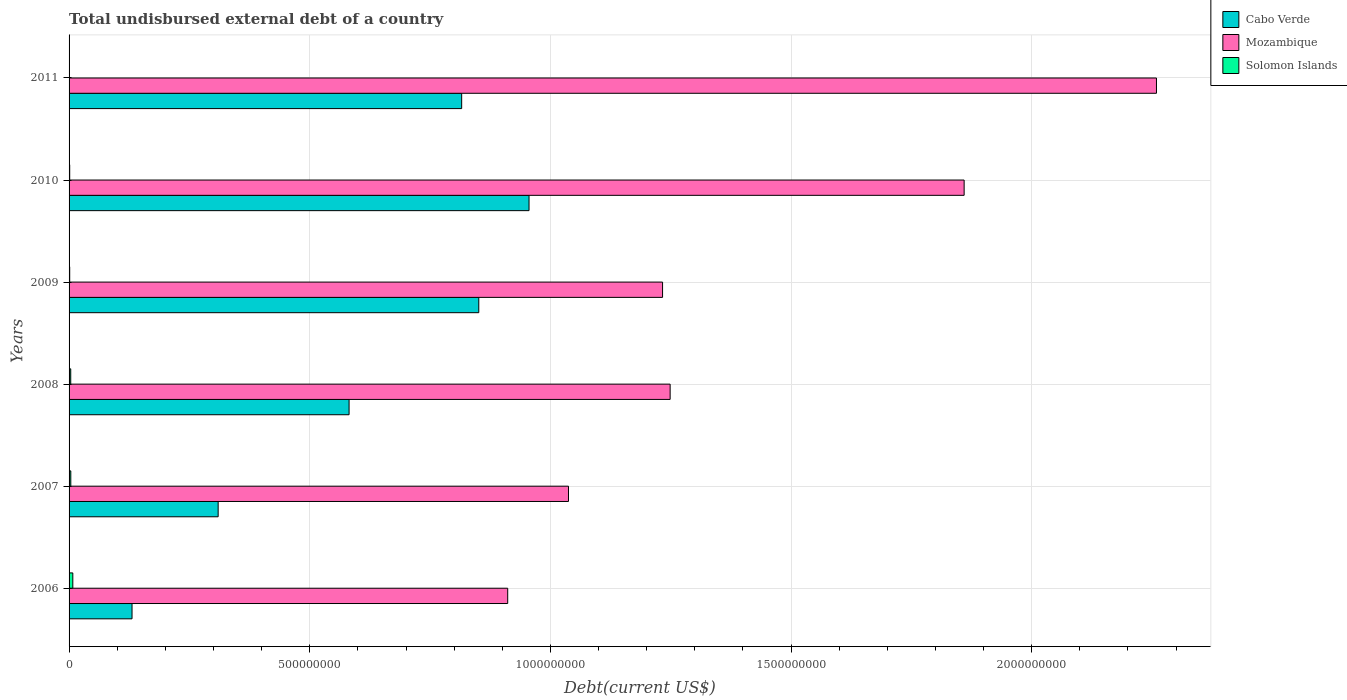How many different coloured bars are there?
Ensure brevity in your answer.  3. How many groups of bars are there?
Give a very brief answer. 6. Are the number of bars per tick equal to the number of legend labels?
Provide a succinct answer. Yes. How many bars are there on the 6th tick from the top?
Your response must be concise. 3. What is the label of the 1st group of bars from the top?
Offer a very short reply. 2011. What is the total undisbursed external debt in Mozambique in 2011?
Ensure brevity in your answer.  2.26e+09. Across all years, what is the maximum total undisbursed external debt in Solomon Islands?
Offer a very short reply. 7.76e+06. Across all years, what is the minimum total undisbursed external debt in Mozambique?
Your answer should be compact. 9.11e+08. In which year was the total undisbursed external debt in Mozambique minimum?
Your answer should be compact. 2006. What is the total total undisbursed external debt in Cabo Verde in the graph?
Keep it short and to the point. 3.64e+09. What is the difference between the total undisbursed external debt in Solomon Islands in 2007 and that in 2009?
Keep it short and to the point. 2.28e+06. What is the difference between the total undisbursed external debt in Mozambique in 2009 and the total undisbursed external debt in Cabo Verde in 2007?
Provide a succinct answer. 9.23e+08. What is the average total undisbursed external debt in Mozambique per year?
Your answer should be very brief. 1.42e+09. In the year 2008, what is the difference between the total undisbursed external debt in Mozambique and total undisbursed external debt in Solomon Islands?
Offer a very short reply. 1.25e+09. In how many years, is the total undisbursed external debt in Cabo Verde greater than 400000000 US$?
Provide a short and direct response. 4. What is the ratio of the total undisbursed external debt in Solomon Islands in 2009 to that in 2010?
Ensure brevity in your answer.  1. What is the difference between the highest and the second highest total undisbursed external debt in Cabo Verde?
Your response must be concise. 1.04e+08. What is the difference between the highest and the lowest total undisbursed external debt in Solomon Islands?
Your answer should be compact. 7.65e+06. In how many years, is the total undisbursed external debt in Solomon Islands greater than the average total undisbursed external debt in Solomon Islands taken over all years?
Keep it short and to the point. 3. What does the 2nd bar from the top in 2006 represents?
Your response must be concise. Mozambique. What does the 2nd bar from the bottom in 2009 represents?
Your answer should be compact. Mozambique. Is it the case that in every year, the sum of the total undisbursed external debt in Mozambique and total undisbursed external debt in Solomon Islands is greater than the total undisbursed external debt in Cabo Verde?
Offer a very short reply. Yes. What is the difference between two consecutive major ticks on the X-axis?
Make the answer very short. 5.00e+08. Are the values on the major ticks of X-axis written in scientific E-notation?
Your answer should be compact. No. Does the graph contain any zero values?
Your answer should be compact. No. Where does the legend appear in the graph?
Provide a succinct answer. Top right. How many legend labels are there?
Your answer should be very brief. 3. What is the title of the graph?
Offer a very short reply. Total undisbursed external debt of a country. Does "Northern Mariana Islands" appear as one of the legend labels in the graph?
Your answer should be very brief. No. What is the label or title of the X-axis?
Make the answer very short. Debt(current US$). What is the Debt(current US$) in Cabo Verde in 2006?
Make the answer very short. 1.31e+08. What is the Debt(current US$) of Mozambique in 2006?
Offer a terse response. 9.11e+08. What is the Debt(current US$) in Solomon Islands in 2006?
Your answer should be compact. 7.76e+06. What is the Debt(current US$) in Cabo Verde in 2007?
Provide a succinct answer. 3.10e+08. What is the Debt(current US$) in Mozambique in 2007?
Give a very brief answer. 1.04e+09. What is the Debt(current US$) in Solomon Islands in 2007?
Offer a very short reply. 3.60e+06. What is the Debt(current US$) in Cabo Verde in 2008?
Offer a very short reply. 5.82e+08. What is the Debt(current US$) of Mozambique in 2008?
Provide a short and direct response. 1.25e+09. What is the Debt(current US$) in Solomon Islands in 2008?
Provide a short and direct response. 3.46e+06. What is the Debt(current US$) of Cabo Verde in 2009?
Make the answer very short. 8.51e+08. What is the Debt(current US$) of Mozambique in 2009?
Keep it short and to the point. 1.23e+09. What is the Debt(current US$) of Solomon Islands in 2009?
Your answer should be compact. 1.32e+06. What is the Debt(current US$) of Cabo Verde in 2010?
Provide a short and direct response. 9.56e+08. What is the Debt(current US$) in Mozambique in 2010?
Your answer should be compact. 1.86e+09. What is the Debt(current US$) of Solomon Islands in 2010?
Your response must be concise. 1.32e+06. What is the Debt(current US$) in Cabo Verde in 2011?
Offer a terse response. 8.16e+08. What is the Debt(current US$) in Mozambique in 2011?
Keep it short and to the point. 2.26e+09. What is the Debt(current US$) in Solomon Islands in 2011?
Provide a short and direct response. 1.14e+05. Across all years, what is the maximum Debt(current US$) of Cabo Verde?
Ensure brevity in your answer.  9.56e+08. Across all years, what is the maximum Debt(current US$) of Mozambique?
Give a very brief answer. 2.26e+09. Across all years, what is the maximum Debt(current US$) of Solomon Islands?
Your response must be concise. 7.76e+06. Across all years, what is the minimum Debt(current US$) of Cabo Verde?
Keep it short and to the point. 1.31e+08. Across all years, what is the minimum Debt(current US$) of Mozambique?
Give a very brief answer. 9.11e+08. Across all years, what is the minimum Debt(current US$) in Solomon Islands?
Provide a succinct answer. 1.14e+05. What is the total Debt(current US$) in Cabo Verde in the graph?
Offer a very short reply. 3.64e+09. What is the total Debt(current US$) of Mozambique in the graph?
Provide a succinct answer. 8.55e+09. What is the total Debt(current US$) in Solomon Islands in the graph?
Your answer should be very brief. 1.76e+07. What is the difference between the Debt(current US$) of Cabo Verde in 2006 and that in 2007?
Offer a very short reply. -1.79e+08. What is the difference between the Debt(current US$) of Mozambique in 2006 and that in 2007?
Give a very brief answer. -1.26e+08. What is the difference between the Debt(current US$) of Solomon Islands in 2006 and that in 2007?
Make the answer very short. 4.16e+06. What is the difference between the Debt(current US$) in Cabo Verde in 2006 and that in 2008?
Make the answer very short. -4.51e+08. What is the difference between the Debt(current US$) of Mozambique in 2006 and that in 2008?
Offer a very short reply. -3.37e+08. What is the difference between the Debt(current US$) in Solomon Islands in 2006 and that in 2008?
Offer a very short reply. 4.30e+06. What is the difference between the Debt(current US$) of Cabo Verde in 2006 and that in 2009?
Your answer should be compact. -7.20e+08. What is the difference between the Debt(current US$) in Mozambique in 2006 and that in 2009?
Keep it short and to the point. -3.22e+08. What is the difference between the Debt(current US$) in Solomon Islands in 2006 and that in 2009?
Give a very brief answer. 6.44e+06. What is the difference between the Debt(current US$) in Cabo Verde in 2006 and that in 2010?
Your response must be concise. -8.25e+08. What is the difference between the Debt(current US$) in Mozambique in 2006 and that in 2010?
Make the answer very short. -9.48e+08. What is the difference between the Debt(current US$) in Solomon Islands in 2006 and that in 2010?
Your answer should be compact. 6.44e+06. What is the difference between the Debt(current US$) of Cabo Verde in 2006 and that in 2011?
Provide a succinct answer. -6.85e+08. What is the difference between the Debt(current US$) in Mozambique in 2006 and that in 2011?
Your answer should be very brief. -1.35e+09. What is the difference between the Debt(current US$) of Solomon Islands in 2006 and that in 2011?
Make the answer very short. 7.65e+06. What is the difference between the Debt(current US$) of Cabo Verde in 2007 and that in 2008?
Keep it short and to the point. -2.72e+08. What is the difference between the Debt(current US$) in Mozambique in 2007 and that in 2008?
Offer a terse response. -2.11e+08. What is the difference between the Debt(current US$) of Solomon Islands in 2007 and that in 2008?
Your response must be concise. 1.39e+05. What is the difference between the Debt(current US$) in Cabo Verde in 2007 and that in 2009?
Keep it short and to the point. -5.41e+08. What is the difference between the Debt(current US$) of Mozambique in 2007 and that in 2009?
Keep it short and to the point. -1.95e+08. What is the difference between the Debt(current US$) in Solomon Islands in 2007 and that in 2009?
Your answer should be compact. 2.28e+06. What is the difference between the Debt(current US$) in Cabo Verde in 2007 and that in 2010?
Give a very brief answer. -6.46e+08. What is the difference between the Debt(current US$) in Mozambique in 2007 and that in 2010?
Give a very brief answer. -8.22e+08. What is the difference between the Debt(current US$) in Solomon Islands in 2007 and that in 2010?
Offer a terse response. 2.28e+06. What is the difference between the Debt(current US$) in Cabo Verde in 2007 and that in 2011?
Keep it short and to the point. -5.06e+08. What is the difference between the Debt(current US$) in Mozambique in 2007 and that in 2011?
Your answer should be very brief. -1.22e+09. What is the difference between the Debt(current US$) of Solomon Islands in 2007 and that in 2011?
Your answer should be compact. 3.49e+06. What is the difference between the Debt(current US$) in Cabo Verde in 2008 and that in 2009?
Your response must be concise. -2.69e+08. What is the difference between the Debt(current US$) in Mozambique in 2008 and that in 2009?
Provide a succinct answer. 1.57e+07. What is the difference between the Debt(current US$) in Solomon Islands in 2008 and that in 2009?
Make the answer very short. 2.14e+06. What is the difference between the Debt(current US$) of Cabo Verde in 2008 and that in 2010?
Your response must be concise. -3.74e+08. What is the difference between the Debt(current US$) in Mozambique in 2008 and that in 2010?
Make the answer very short. -6.11e+08. What is the difference between the Debt(current US$) in Solomon Islands in 2008 and that in 2010?
Your answer should be compact. 2.14e+06. What is the difference between the Debt(current US$) in Cabo Verde in 2008 and that in 2011?
Provide a succinct answer. -2.34e+08. What is the difference between the Debt(current US$) in Mozambique in 2008 and that in 2011?
Keep it short and to the point. -1.01e+09. What is the difference between the Debt(current US$) in Solomon Islands in 2008 and that in 2011?
Ensure brevity in your answer.  3.35e+06. What is the difference between the Debt(current US$) in Cabo Verde in 2009 and that in 2010?
Your response must be concise. -1.04e+08. What is the difference between the Debt(current US$) in Mozambique in 2009 and that in 2010?
Your response must be concise. -6.27e+08. What is the difference between the Debt(current US$) of Solomon Islands in 2009 and that in 2010?
Offer a terse response. 2000. What is the difference between the Debt(current US$) in Cabo Verde in 2009 and that in 2011?
Make the answer very short. 3.55e+07. What is the difference between the Debt(current US$) of Mozambique in 2009 and that in 2011?
Make the answer very short. -1.03e+09. What is the difference between the Debt(current US$) of Solomon Islands in 2009 and that in 2011?
Your answer should be very brief. 1.21e+06. What is the difference between the Debt(current US$) of Cabo Verde in 2010 and that in 2011?
Provide a succinct answer. 1.40e+08. What is the difference between the Debt(current US$) in Mozambique in 2010 and that in 2011?
Provide a succinct answer. -4.00e+08. What is the difference between the Debt(current US$) in Solomon Islands in 2010 and that in 2011?
Your answer should be very brief. 1.21e+06. What is the difference between the Debt(current US$) in Cabo Verde in 2006 and the Debt(current US$) in Mozambique in 2007?
Your answer should be very brief. -9.07e+08. What is the difference between the Debt(current US$) in Cabo Verde in 2006 and the Debt(current US$) in Solomon Islands in 2007?
Give a very brief answer. 1.27e+08. What is the difference between the Debt(current US$) in Mozambique in 2006 and the Debt(current US$) in Solomon Islands in 2007?
Provide a succinct answer. 9.08e+08. What is the difference between the Debt(current US$) in Cabo Verde in 2006 and the Debt(current US$) in Mozambique in 2008?
Your answer should be compact. -1.12e+09. What is the difference between the Debt(current US$) of Cabo Verde in 2006 and the Debt(current US$) of Solomon Islands in 2008?
Give a very brief answer. 1.27e+08. What is the difference between the Debt(current US$) of Mozambique in 2006 and the Debt(current US$) of Solomon Islands in 2008?
Provide a short and direct response. 9.08e+08. What is the difference between the Debt(current US$) of Cabo Verde in 2006 and the Debt(current US$) of Mozambique in 2009?
Give a very brief answer. -1.10e+09. What is the difference between the Debt(current US$) in Cabo Verde in 2006 and the Debt(current US$) in Solomon Islands in 2009?
Offer a terse response. 1.29e+08. What is the difference between the Debt(current US$) of Mozambique in 2006 and the Debt(current US$) of Solomon Islands in 2009?
Offer a terse response. 9.10e+08. What is the difference between the Debt(current US$) of Cabo Verde in 2006 and the Debt(current US$) of Mozambique in 2010?
Provide a succinct answer. -1.73e+09. What is the difference between the Debt(current US$) in Cabo Verde in 2006 and the Debt(current US$) in Solomon Islands in 2010?
Your answer should be very brief. 1.29e+08. What is the difference between the Debt(current US$) of Mozambique in 2006 and the Debt(current US$) of Solomon Islands in 2010?
Your answer should be very brief. 9.10e+08. What is the difference between the Debt(current US$) of Cabo Verde in 2006 and the Debt(current US$) of Mozambique in 2011?
Your answer should be very brief. -2.13e+09. What is the difference between the Debt(current US$) in Cabo Verde in 2006 and the Debt(current US$) in Solomon Islands in 2011?
Your answer should be compact. 1.31e+08. What is the difference between the Debt(current US$) of Mozambique in 2006 and the Debt(current US$) of Solomon Islands in 2011?
Provide a short and direct response. 9.11e+08. What is the difference between the Debt(current US$) of Cabo Verde in 2007 and the Debt(current US$) of Mozambique in 2008?
Ensure brevity in your answer.  -9.39e+08. What is the difference between the Debt(current US$) in Cabo Verde in 2007 and the Debt(current US$) in Solomon Islands in 2008?
Give a very brief answer. 3.06e+08. What is the difference between the Debt(current US$) in Mozambique in 2007 and the Debt(current US$) in Solomon Islands in 2008?
Your answer should be very brief. 1.03e+09. What is the difference between the Debt(current US$) of Cabo Verde in 2007 and the Debt(current US$) of Mozambique in 2009?
Your answer should be very brief. -9.23e+08. What is the difference between the Debt(current US$) of Cabo Verde in 2007 and the Debt(current US$) of Solomon Islands in 2009?
Make the answer very short. 3.08e+08. What is the difference between the Debt(current US$) of Mozambique in 2007 and the Debt(current US$) of Solomon Islands in 2009?
Keep it short and to the point. 1.04e+09. What is the difference between the Debt(current US$) in Cabo Verde in 2007 and the Debt(current US$) in Mozambique in 2010?
Ensure brevity in your answer.  -1.55e+09. What is the difference between the Debt(current US$) in Cabo Verde in 2007 and the Debt(current US$) in Solomon Islands in 2010?
Offer a terse response. 3.08e+08. What is the difference between the Debt(current US$) in Mozambique in 2007 and the Debt(current US$) in Solomon Islands in 2010?
Offer a very short reply. 1.04e+09. What is the difference between the Debt(current US$) of Cabo Verde in 2007 and the Debt(current US$) of Mozambique in 2011?
Your answer should be very brief. -1.95e+09. What is the difference between the Debt(current US$) of Cabo Verde in 2007 and the Debt(current US$) of Solomon Islands in 2011?
Give a very brief answer. 3.10e+08. What is the difference between the Debt(current US$) of Mozambique in 2007 and the Debt(current US$) of Solomon Islands in 2011?
Give a very brief answer. 1.04e+09. What is the difference between the Debt(current US$) of Cabo Verde in 2008 and the Debt(current US$) of Mozambique in 2009?
Make the answer very short. -6.51e+08. What is the difference between the Debt(current US$) of Cabo Verde in 2008 and the Debt(current US$) of Solomon Islands in 2009?
Your answer should be compact. 5.80e+08. What is the difference between the Debt(current US$) in Mozambique in 2008 and the Debt(current US$) in Solomon Islands in 2009?
Keep it short and to the point. 1.25e+09. What is the difference between the Debt(current US$) of Cabo Verde in 2008 and the Debt(current US$) of Mozambique in 2010?
Your response must be concise. -1.28e+09. What is the difference between the Debt(current US$) of Cabo Verde in 2008 and the Debt(current US$) of Solomon Islands in 2010?
Your response must be concise. 5.80e+08. What is the difference between the Debt(current US$) of Mozambique in 2008 and the Debt(current US$) of Solomon Islands in 2010?
Keep it short and to the point. 1.25e+09. What is the difference between the Debt(current US$) in Cabo Verde in 2008 and the Debt(current US$) in Mozambique in 2011?
Keep it short and to the point. -1.68e+09. What is the difference between the Debt(current US$) of Cabo Verde in 2008 and the Debt(current US$) of Solomon Islands in 2011?
Your answer should be compact. 5.82e+08. What is the difference between the Debt(current US$) in Mozambique in 2008 and the Debt(current US$) in Solomon Islands in 2011?
Your answer should be compact. 1.25e+09. What is the difference between the Debt(current US$) of Cabo Verde in 2009 and the Debt(current US$) of Mozambique in 2010?
Your response must be concise. -1.01e+09. What is the difference between the Debt(current US$) in Cabo Verde in 2009 and the Debt(current US$) in Solomon Islands in 2010?
Offer a very short reply. 8.50e+08. What is the difference between the Debt(current US$) in Mozambique in 2009 and the Debt(current US$) in Solomon Islands in 2010?
Your answer should be compact. 1.23e+09. What is the difference between the Debt(current US$) in Cabo Verde in 2009 and the Debt(current US$) in Mozambique in 2011?
Your answer should be very brief. -1.41e+09. What is the difference between the Debt(current US$) of Cabo Verde in 2009 and the Debt(current US$) of Solomon Islands in 2011?
Keep it short and to the point. 8.51e+08. What is the difference between the Debt(current US$) of Mozambique in 2009 and the Debt(current US$) of Solomon Islands in 2011?
Make the answer very short. 1.23e+09. What is the difference between the Debt(current US$) of Cabo Verde in 2010 and the Debt(current US$) of Mozambique in 2011?
Offer a very short reply. -1.30e+09. What is the difference between the Debt(current US$) of Cabo Verde in 2010 and the Debt(current US$) of Solomon Islands in 2011?
Offer a terse response. 9.55e+08. What is the difference between the Debt(current US$) in Mozambique in 2010 and the Debt(current US$) in Solomon Islands in 2011?
Offer a very short reply. 1.86e+09. What is the average Debt(current US$) in Cabo Verde per year?
Make the answer very short. 6.07e+08. What is the average Debt(current US$) in Mozambique per year?
Provide a short and direct response. 1.42e+09. What is the average Debt(current US$) in Solomon Islands per year?
Make the answer very short. 2.93e+06. In the year 2006, what is the difference between the Debt(current US$) of Cabo Verde and Debt(current US$) of Mozambique?
Make the answer very short. -7.81e+08. In the year 2006, what is the difference between the Debt(current US$) of Cabo Verde and Debt(current US$) of Solomon Islands?
Make the answer very short. 1.23e+08. In the year 2006, what is the difference between the Debt(current US$) in Mozambique and Debt(current US$) in Solomon Islands?
Provide a succinct answer. 9.04e+08. In the year 2007, what is the difference between the Debt(current US$) in Cabo Verde and Debt(current US$) in Mozambique?
Offer a terse response. -7.28e+08. In the year 2007, what is the difference between the Debt(current US$) in Cabo Verde and Debt(current US$) in Solomon Islands?
Offer a terse response. 3.06e+08. In the year 2007, what is the difference between the Debt(current US$) of Mozambique and Debt(current US$) of Solomon Islands?
Provide a short and direct response. 1.03e+09. In the year 2008, what is the difference between the Debt(current US$) in Cabo Verde and Debt(current US$) in Mozambique?
Make the answer very short. -6.67e+08. In the year 2008, what is the difference between the Debt(current US$) in Cabo Verde and Debt(current US$) in Solomon Islands?
Ensure brevity in your answer.  5.78e+08. In the year 2008, what is the difference between the Debt(current US$) in Mozambique and Debt(current US$) in Solomon Islands?
Offer a terse response. 1.25e+09. In the year 2009, what is the difference between the Debt(current US$) of Cabo Verde and Debt(current US$) of Mozambique?
Ensure brevity in your answer.  -3.82e+08. In the year 2009, what is the difference between the Debt(current US$) of Cabo Verde and Debt(current US$) of Solomon Islands?
Provide a short and direct response. 8.50e+08. In the year 2009, what is the difference between the Debt(current US$) of Mozambique and Debt(current US$) of Solomon Islands?
Your answer should be very brief. 1.23e+09. In the year 2010, what is the difference between the Debt(current US$) of Cabo Verde and Debt(current US$) of Mozambique?
Offer a very short reply. -9.04e+08. In the year 2010, what is the difference between the Debt(current US$) in Cabo Verde and Debt(current US$) in Solomon Islands?
Make the answer very short. 9.54e+08. In the year 2010, what is the difference between the Debt(current US$) of Mozambique and Debt(current US$) of Solomon Islands?
Keep it short and to the point. 1.86e+09. In the year 2011, what is the difference between the Debt(current US$) of Cabo Verde and Debt(current US$) of Mozambique?
Offer a terse response. -1.44e+09. In the year 2011, what is the difference between the Debt(current US$) of Cabo Verde and Debt(current US$) of Solomon Islands?
Your answer should be very brief. 8.16e+08. In the year 2011, what is the difference between the Debt(current US$) of Mozambique and Debt(current US$) of Solomon Islands?
Your answer should be very brief. 2.26e+09. What is the ratio of the Debt(current US$) in Cabo Verde in 2006 to that in 2007?
Your answer should be very brief. 0.42. What is the ratio of the Debt(current US$) in Mozambique in 2006 to that in 2007?
Give a very brief answer. 0.88. What is the ratio of the Debt(current US$) in Solomon Islands in 2006 to that in 2007?
Ensure brevity in your answer.  2.16. What is the ratio of the Debt(current US$) of Cabo Verde in 2006 to that in 2008?
Your response must be concise. 0.22. What is the ratio of the Debt(current US$) of Mozambique in 2006 to that in 2008?
Your answer should be compact. 0.73. What is the ratio of the Debt(current US$) in Solomon Islands in 2006 to that in 2008?
Offer a terse response. 2.24. What is the ratio of the Debt(current US$) of Cabo Verde in 2006 to that in 2009?
Provide a short and direct response. 0.15. What is the ratio of the Debt(current US$) of Mozambique in 2006 to that in 2009?
Your answer should be very brief. 0.74. What is the ratio of the Debt(current US$) of Solomon Islands in 2006 to that in 2009?
Offer a very short reply. 5.86. What is the ratio of the Debt(current US$) of Cabo Verde in 2006 to that in 2010?
Offer a terse response. 0.14. What is the ratio of the Debt(current US$) of Mozambique in 2006 to that in 2010?
Give a very brief answer. 0.49. What is the ratio of the Debt(current US$) of Solomon Islands in 2006 to that in 2010?
Keep it short and to the point. 5.87. What is the ratio of the Debt(current US$) of Cabo Verde in 2006 to that in 2011?
Make the answer very short. 0.16. What is the ratio of the Debt(current US$) of Mozambique in 2006 to that in 2011?
Give a very brief answer. 0.4. What is the ratio of the Debt(current US$) of Solomon Islands in 2006 to that in 2011?
Give a very brief answer. 68.11. What is the ratio of the Debt(current US$) in Cabo Verde in 2007 to that in 2008?
Your response must be concise. 0.53. What is the ratio of the Debt(current US$) in Mozambique in 2007 to that in 2008?
Give a very brief answer. 0.83. What is the ratio of the Debt(current US$) of Solomon Islands in 2007 to that in 2008?
Provide a succinct answer. 1.04. What is the ratio of the Debt(current US$) in Cabo Verde in 2007 to that in 2009?
Offer a terse response. 0.36. What is the ratio of the Debt(current US$) in Mozambique in 2007 to that in 2009?
Ensure brevity in your answer.  0.84. What is the ratio of the Debt(current US$) in Solomon Islands in 2007 to that in 2009?
Keep it short and to the point. 2.72. What is the ratio of the Debt(current US$) in Cabo Verde in 2007 to that in 2010?
Keep it short and to the point. 0.32. What is the ratio of the Debt(current US$) of Mozambique in 2007 to that in 2010?
Your answer should be very brief. 0.56. What is the ratio of the Debt(current US$) of Solomon Islands in 2007 to that in 2010?
Your answer should be compact. 2.72. What is the ratio of the Debt(current US$) in Cabo Verde in 2007 to that in 2011?
Provide a succinct answer. 0.38. What is the ratio of the Debt(current US$) of Mozambique in 2007 to that in 2011?
Make the answer very short. 0.46. What is the ratio of the Debt(current US$) of Solomon Islands in 2007 to that in 2011?
Ensure brevity in your answer.  31.6. What is the ratio of the Debt(current US$) of Cabo Verde in 2008 to that in 2009?
Ensure brevity in your answer.  0.68. What is the ratio of the Debt(current US$) in Mozambique in 2008 to that in 2009?
Make the answer very short. 1.01. What is the ratio of the Debt(current US$) in Solomon Islands in 2008 to that in 2009?
Offer a terse response. 2.62. What is the ratio of the Debt(current US$) of Cabo Verde in 2008 to that in 2010?
Your response must be concise. 0.61. What is the ratio of the Debt(current US$) of Mozambique in 2008 to that in 2010?
Your answer should be very brief. 0.67. What is the ratio of the Debt(current US$) of Solomon Islands in 2008 to that in 2010?
Provide a succinct answer. 2.62. What is the ratio of the Debt(current US$) in Cabo Verde in 2008 to that in 2011?
Your answer should be very brief. 0.71. What is the ratio of the Debt(current US$) of Mozambique in 2008 to that in 2011?
Provide a short and direct response. 0.55. What is the ratio of the Debt(current US$) of Solomon Islands in 2008 to that in 2011?
Ensure brevity in your answer.  30.38. What is the ratio of the Debt(current US$) of Cabo Verde in 2009 to that in 2010?
Your answer should be very brief. 0.89. What is the ratio of the Debt(current US$) in Mozambique in 2009 to that in 2010?
Your answer should be very brief. 0.66. What is the ratio of the Debt(current US$) in Cabo Verde in 2009 to that in 2011?
Provide a succinct answer. 1.04. What is the ratio of the Debt(current US$) of Mozambique in 2009 to that in 2011?
Your response must be concise. 0.55. What is the ratio of the Debt(current US$) in Solomon Islands in 2009 to that in 2011?
Provide a short and direct response. 11.61. What is the ratio of the Debt(current US$) in Cabo Verde in 2010 to that in 2011?
Keep it short and to the point. 1.17. What is the ratio of the Debt(current US$) in Mozambique in 2010 to that in 2011?
Your response must be concise. 0.82. What is the ratio of the Debt(current US$) in Solomon Islands in 2010 to that in 2011?
Your response must be concise. 11.6. What is the difference between the highest and the second highest Debt(current US$) of Cabo Verde?
Ensure brevity in your answer.  1.04e+08. What is the difference between the highest and the second highest Debt(current US$) of Mozambique?
Offer a very short reply. 4.00e+08. What is the difference between the highest and the second highest Debt(current US$) of Solomon Islands?
Ensure brevity in your answer.  4.16e+06. What is the difference between the highest and the lowest Debt(current US$) of Cabo Verde?
Make the answer very short. 8.25e+08. What is the difference between the highest and the lowest Debt(current US$) in Mozambique?
Ensure brevity in your answer.  1.35e+09. What is the difference between the highest and the lowest Debt(current US$) of Solomon Islands?
Offer a terse response. 7.65e+06. 